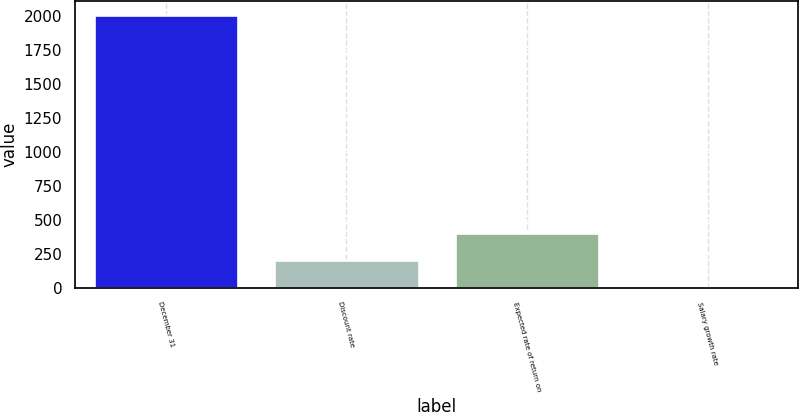Convert chart. <chart><loc_0><loc_0><loc_500><loc_500><bar_chart><fcel>December 31<fcel>Discount rate<fcel>Expected rate of return on<fcel>Salary growth rate<nl><fcel>2007<fcel>204.75<fcel>405<fcel>4.5<nl></chart> 